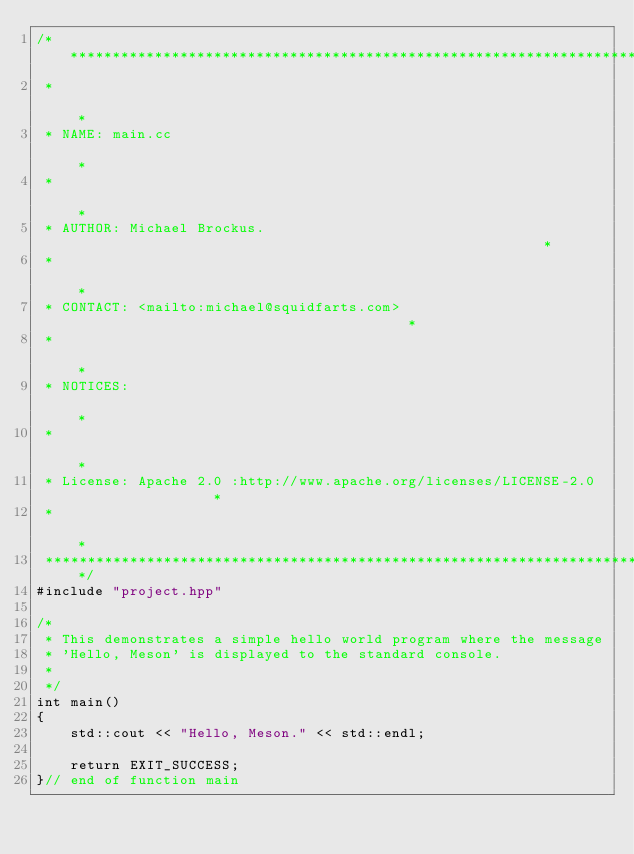Convert code to text. <code><loc_0><loc_0><loc_500><loc_500><_C++_>/***********************************************************************************
 *                                                                                 *
 * NAME: main.cc                                                                   *
 *                                                                                 *
 * AUTHOR: Michael Brockus.                                                        *
 *                                                                                 *
 * CONTACT: <mailto:michael@squidfarts.com>                                        *
 *                                                                                 *
 * NOTICES:                                                                        *
 *                                                                                 *
 * License: Apache 2.0 :http://www.apache.org/licenses/LICENSE-2.0                 *
 *                                                                                 *
 ***********************************************************************************/
#include "project.hpp"

/*
 * This demonstrates a simple hello world program where the message
 * 'Hello, Meson' is displayed to the standard console.
 *
 */
int main()
{
    std::cout << "Hello, Meson." << std::endl;

    return EXIT_SUCCESS;
}// end of function main
</code> 